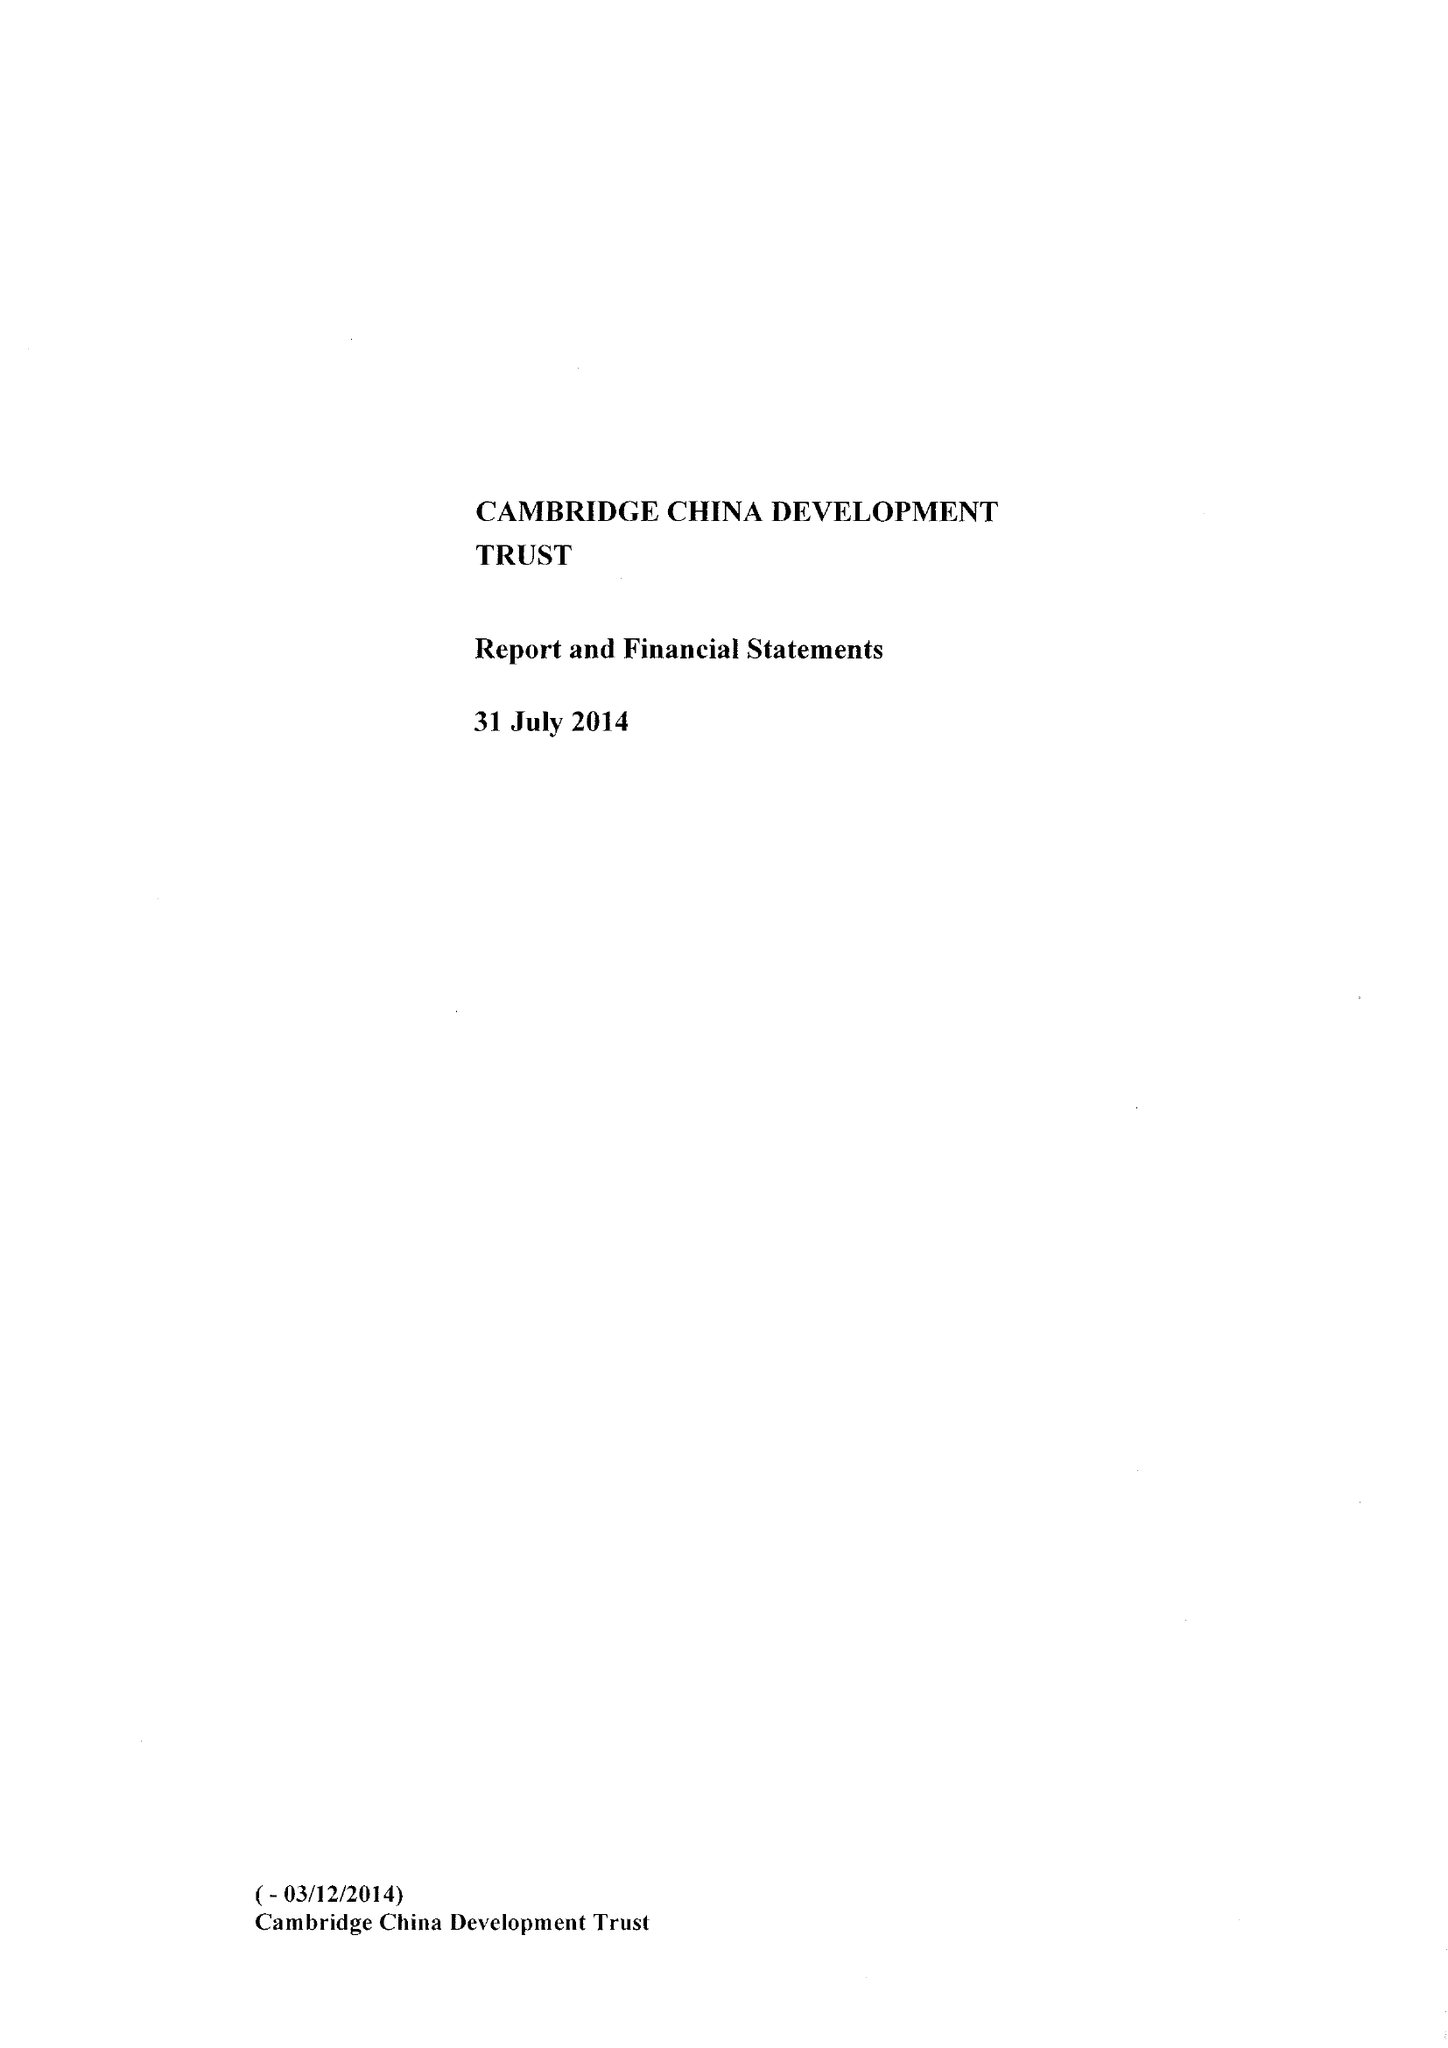What is the value for the address__postcode?
Answer the question using a single word or phrase. CB2 1TQ 